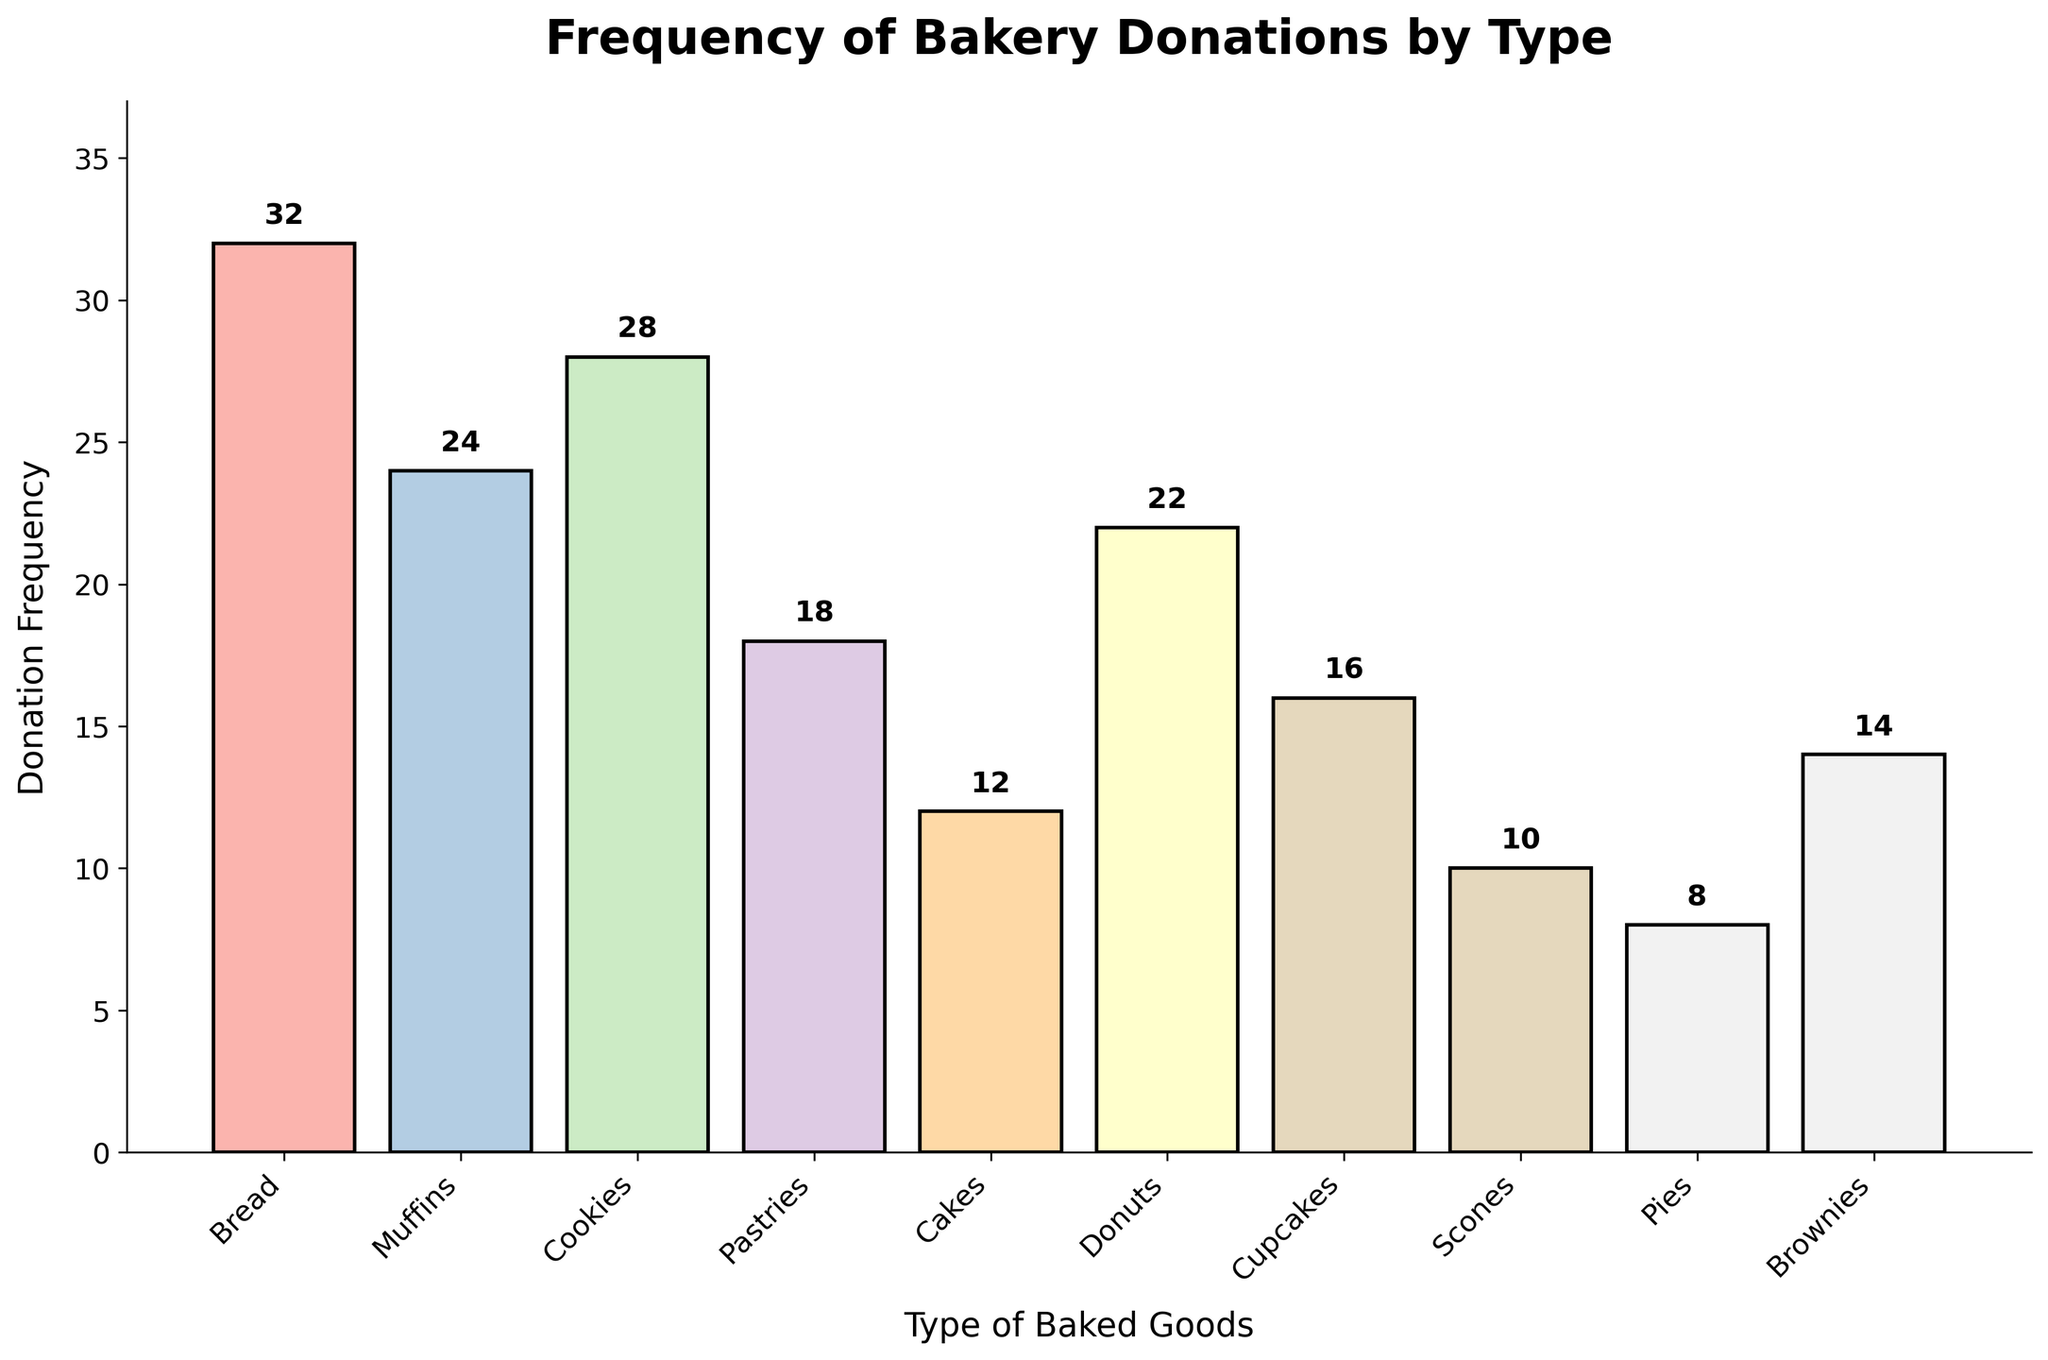What is the title of the histogram? The title of a histogram is usually found at the top of the figure. In this case, the title is placed prominently in bold. It reads, "Frequency of Bakery Donations by Type."
Answer: Frequency of Bakery Donations by Type How many different types of baked goods are represented in the histogram? The number of different types of baked goods can be determined by counting the bars in the histogram. Each bar represents a unique type of baked good. There are 10 different types of baked goods shown.
Answer: 10 Which type of baked good has the highest donation frequency? To find the type with the highest donation frequency, look for the tallest bar in the histogram. The tallest bar corresponds to bread, with a frequency of 32.
Answer: Bread What's the difference between the donation frequencies of cookies and cakes? Find the heights of the bars corresponding to cookies and cakes. The frequency for cookies is 28 and for cakes is 12. The difference is calculated as 28 - 12.
Answer: 16 How does the donation frequency of pastries compare to muffins? To compare the donation frequencies, observe the heights of the bars for pastries and muffins. Pastries have a frequency of 18, whereas muffins have a frequency of 24.
Answer: Muffins have a higher frequency What is the average donation frequency of bread, muffins, and cookies? To find the average, sum the frequencies of bread (32), muffins (24), and cookies (28), then divide by the number of items, which is 3. The calculation is (32 + 24 + 28) / 3.
Answer: 28 Which type of baked good has the lowest donation frequency? To determine the lowest donation frequency, find the shortest bar in the histogram. The shortest bar corresponds to pies, with a frequency of 8.
Answer: Pies What is the total donation frequency for all the baked goods combined? Sum the frequencies of all baked goods: 32 + 24 + 28 + 18 + 12 + 22 + 16 + 10 + 8 + 14. This gives the total donation frequency.
Answer: 184 Between donuts and cupcakes, which has more donations and by how much? Compare the heights of the bars for donuts and cupcakes. Donuts have a frequency of 22 and cupcakes have a frequency of 16. The difference is calculated as 22 - 16.
Answer: Donuts by 6 Are there any types of baked goods with equal donation frequencies? Scan the histogram to check if any bars have the same height. In this case, no two types share the same donation frequency, so the answer is no.
Answer: No 